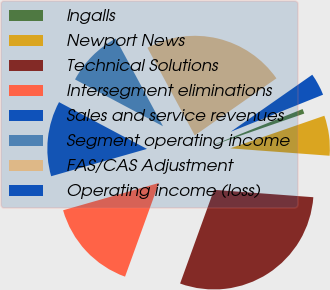Convert chart to OTSL. <chart><loc_0><loc_0><loc_500><loc_500><pie_chart><fcel>Ingalls<fcel>Newport News<fcel>Technical Solutions<fcel>Intersegment eliminations<fcel>Sales and service revenues<fcel>Segment operating income<fcel>FAS/CAS Adjustment<fcel>Operating income (loss)<nl><fcel>0.77%<fcel>6.49%<fcel>29.34%<fcel>15.06%<fcel>12.2%<fcel>9.34%<fcel>23.17%<fcel>3.63%<nl></chart> 